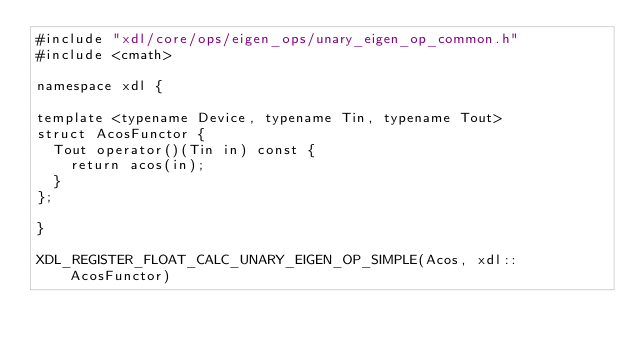<code> <loc_0><loc_0><loc_500><loc_500><_Cuda_>#include "xdl/core/ops/eigen_ops/unary_eigen_op_common.h"
#include <cmath>

namespace xdl {

template <typename Device, typename Tin, typename Tout>
struct AcosFunctor {
  Tout operator()(Tin in) const {
    return acos(in);
  }
};

}

XDL_REGISTER_FLOAT_CALC_UNARY_EIGEN_OP_SIMPLE(Acos, xdl::AcosFunctor)
</code> 